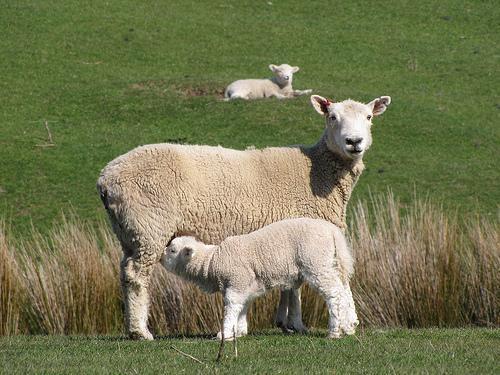How many sheep can be seen?
Give a very brief answer. 3. How many babies are in front of the mother sheep?
Give a very brief answer. 1. 